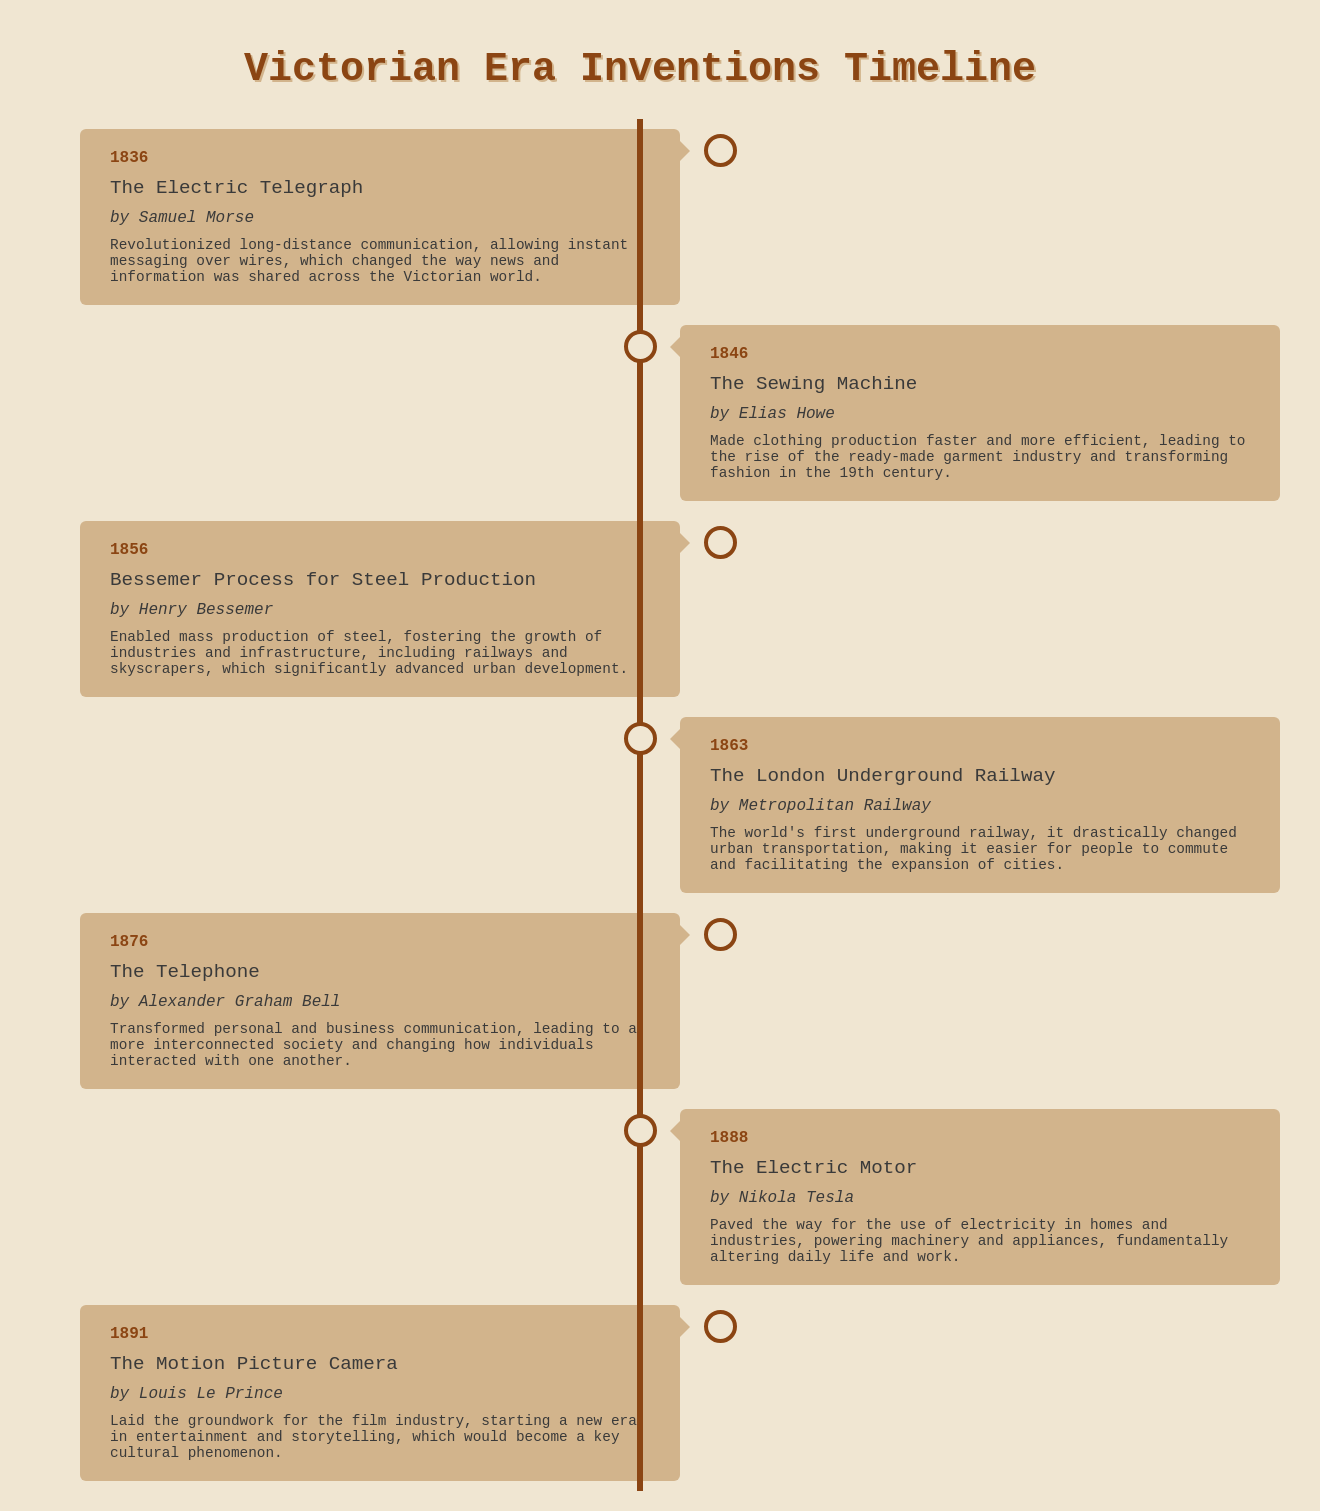what year was the Electric Telegraph invented? The year of the Electric Telegraph invention is specified in the document as 1836.
Answer: 1836 who invented the Sewing Machine? The inventor of the Sewing Machine is listed as Elias Howe in the document.
Answer: Elias Howe what was the impact of the Bessemer Process for Steel Production? The document states that it enabled mass production of steel, which fostered the growth of industries and infrastructure.
Answer: Mass production of steel what invention was created in 1876? The invention created in 1876, as per the document, is the Telephone.
Answer: Telephone which invention significantly changed urban transportation? The London Underground Railway is noted in the document as dramatically changing urban transportation.
Answer: The London Underground Railway who is credited with the invention of the Motion Picture Camera? The document attributes the invention of the Motion Picture Camera to Louis Le Prince.
Answer: Louis Le Prince how did the invention of the Electric Motor impact daily life? According to the document, the Electric Motor fundamentally altered daily life and work by powering machinery and appliances.
Answer: Powered machinery and appliances what year was the telephone invented? The document indicates that the Telephone was invented in 1876.
Answer: 1876 what is the timeline format used in the document? The document uses a timeline format visually represented with containers for each invention, alternating left and right.
Answer: Timeline format 